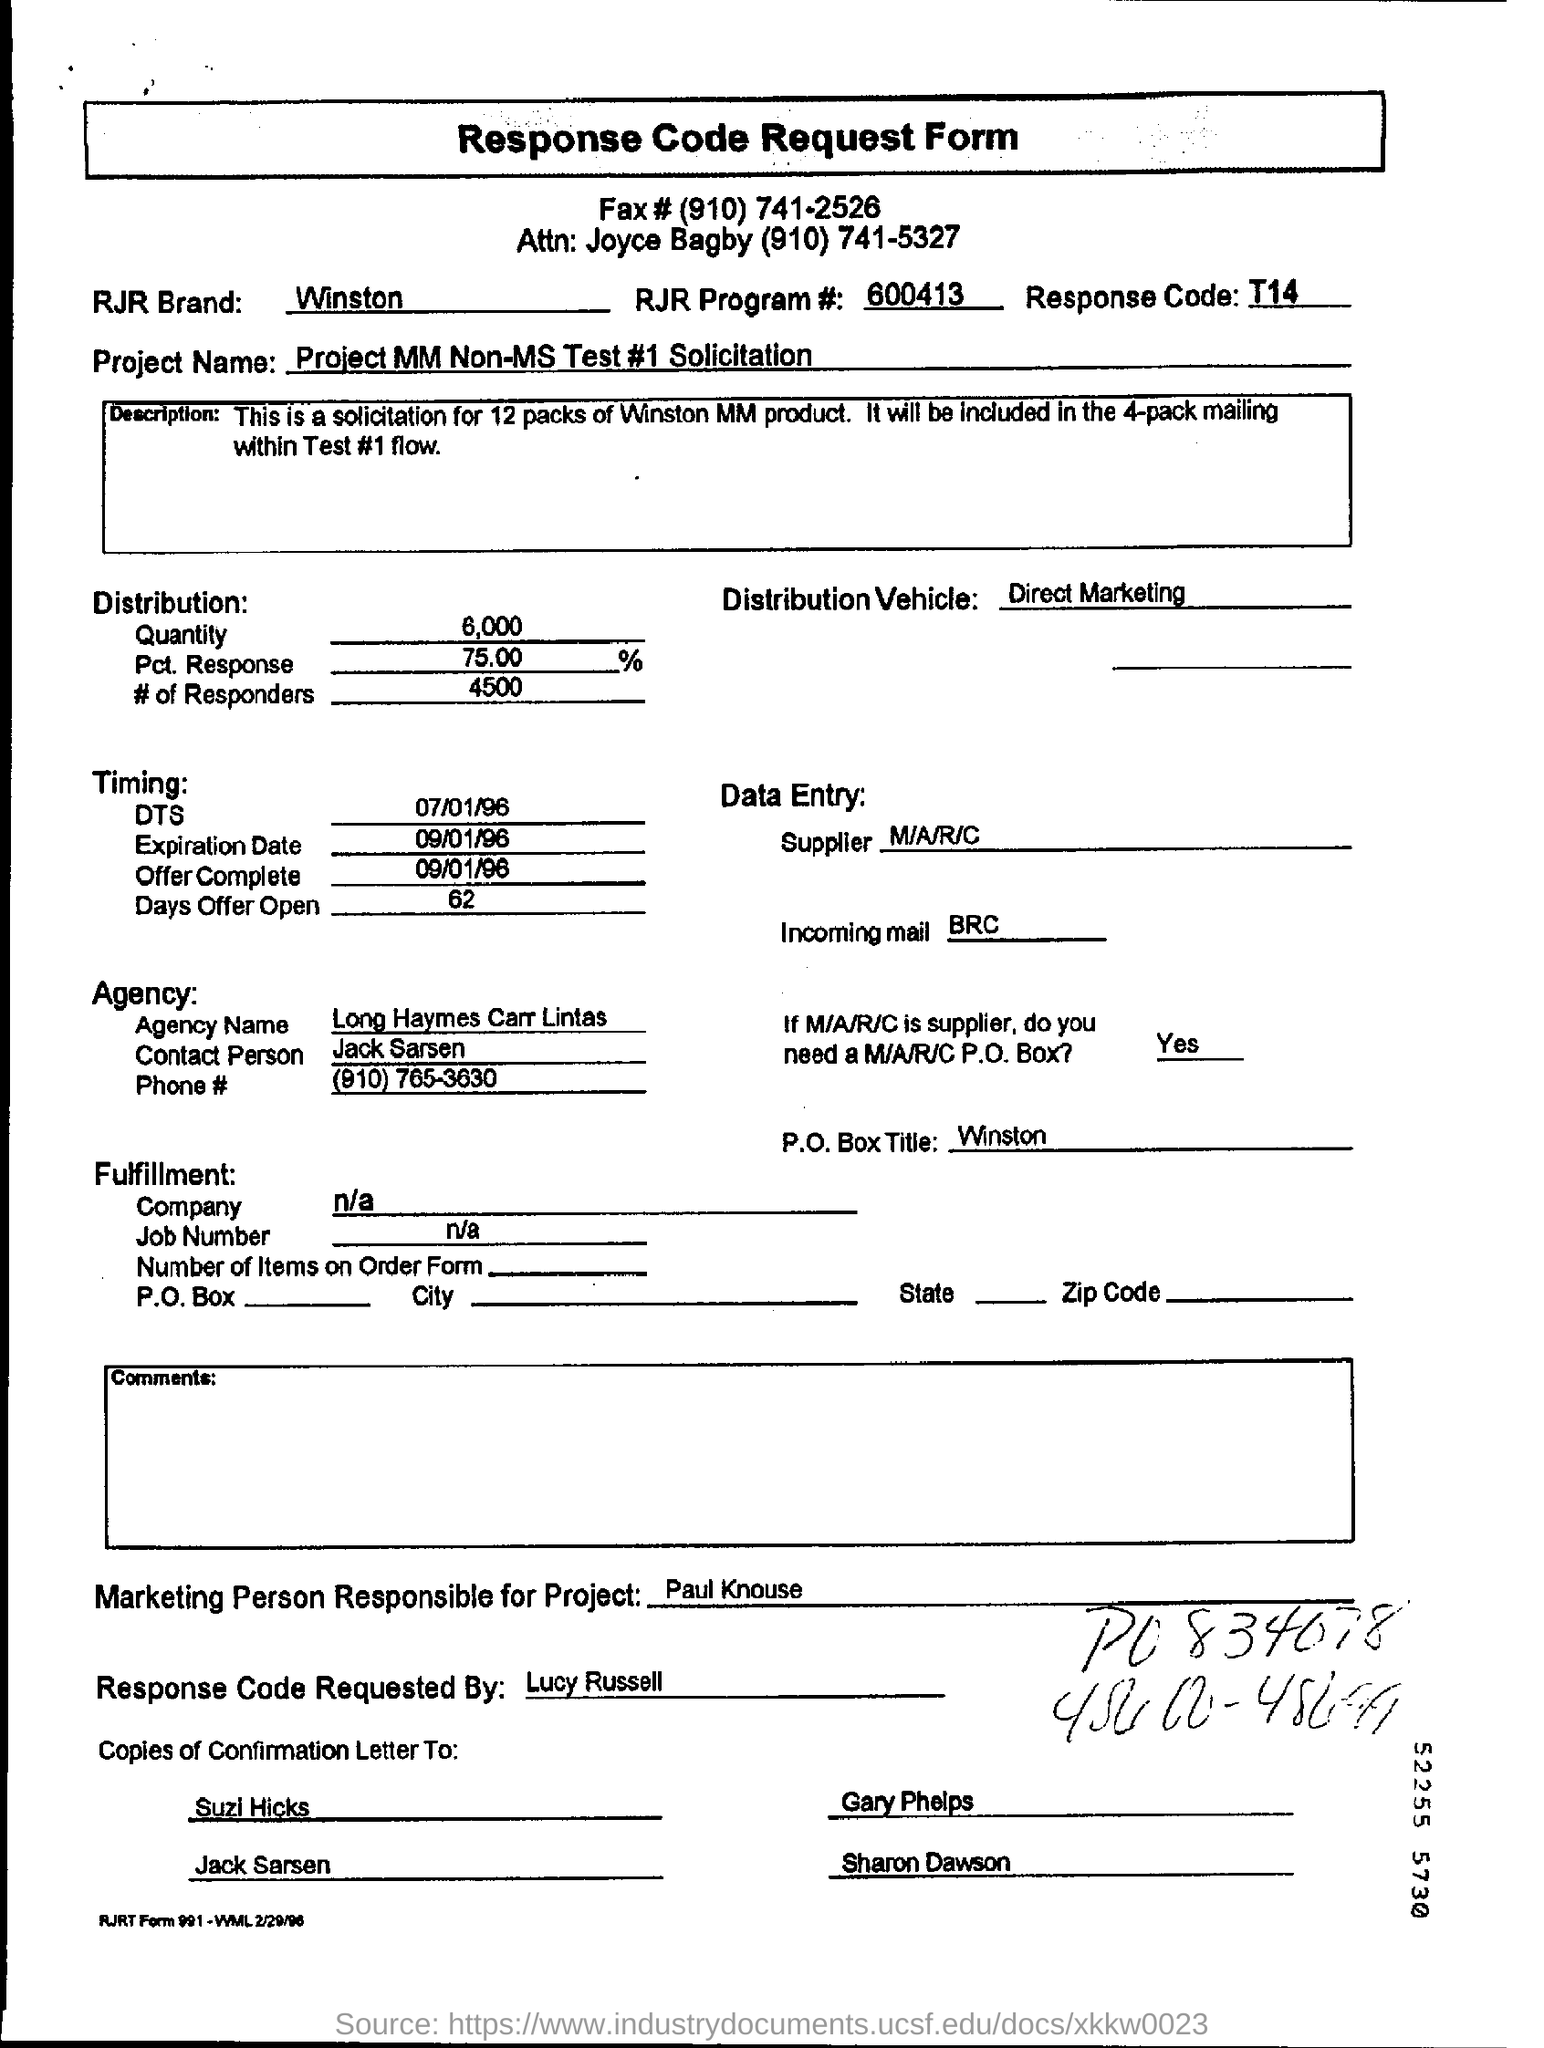Who will be the contact person of the agency?
Provide a succinct answer. Jack sarsen. What is the p.o.box title?
Your answer should be compact. Winston. 